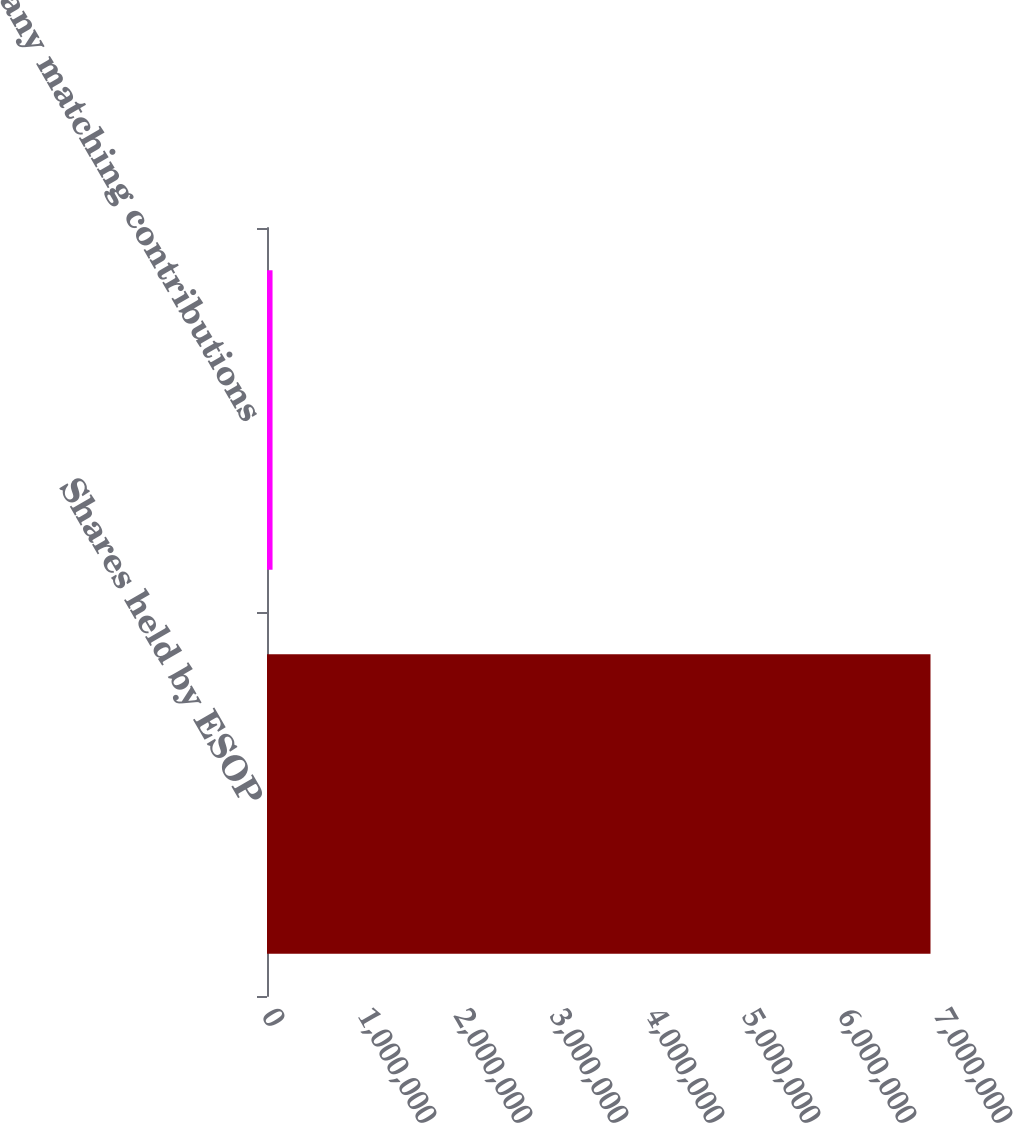Convert chart to OTSL. <chart><loc_0><loc_0><loc_500><loc_500><bar_chart><fcel>Shares held by ESOP<fcel>Company matching contributions<nl><fcel>6.91144e+06<fcel>57766<nl></chart> 